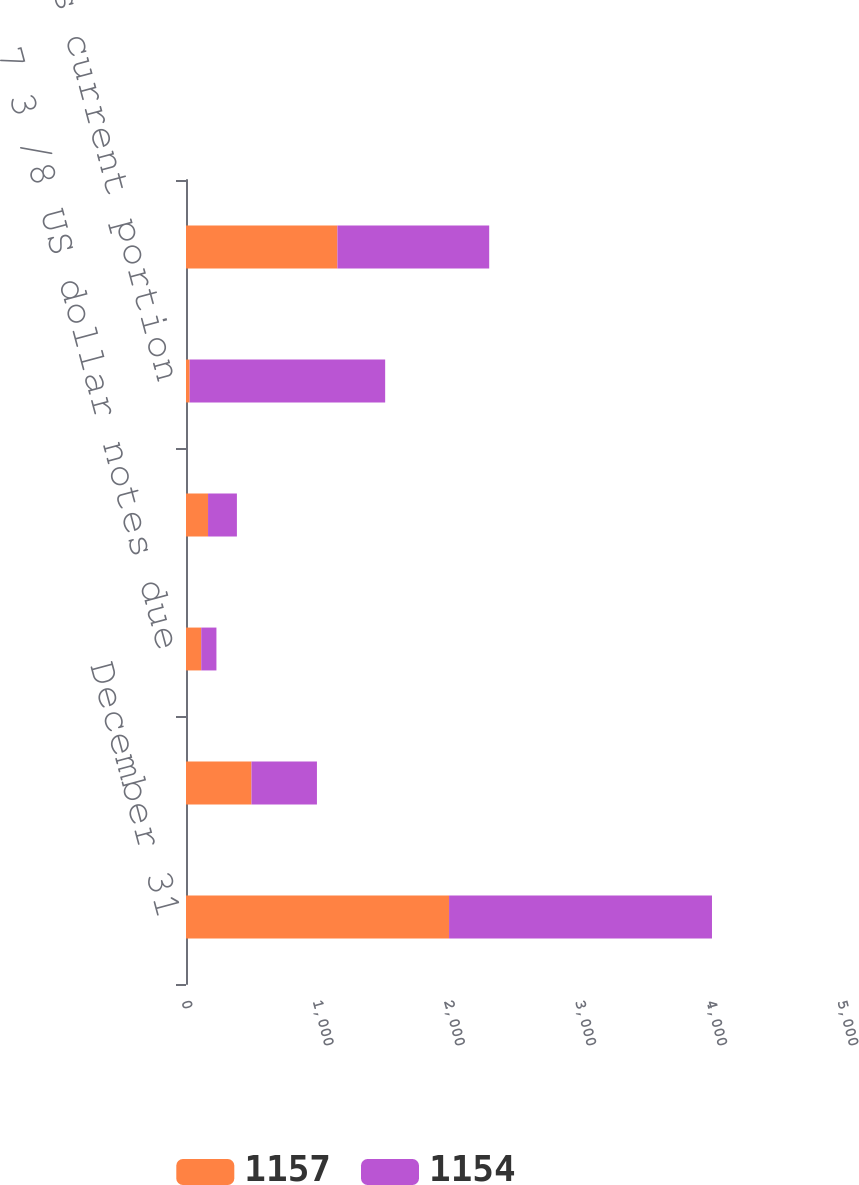<chart> <loc_0><loc_0><loc_500><loc_500><stacked_bar_chart><ecel><fcel>December 31<fcel>5 3 /4 US dollar notes due<fcel>7 3 /8 US dollar notes due<fcel>Other due through 2014 12<fcel>Less current portion<fcel>Long-term debt<nl><fcel>1157<fcel>2005<fcel>499<fcel>116<fcel>168<fcel>28<fcel>1154<nl><fcel>1154<fcel>2004<fcel>499<fcel>116<fcel>220<fcel>1490<fcel>1157<nl></chart> 